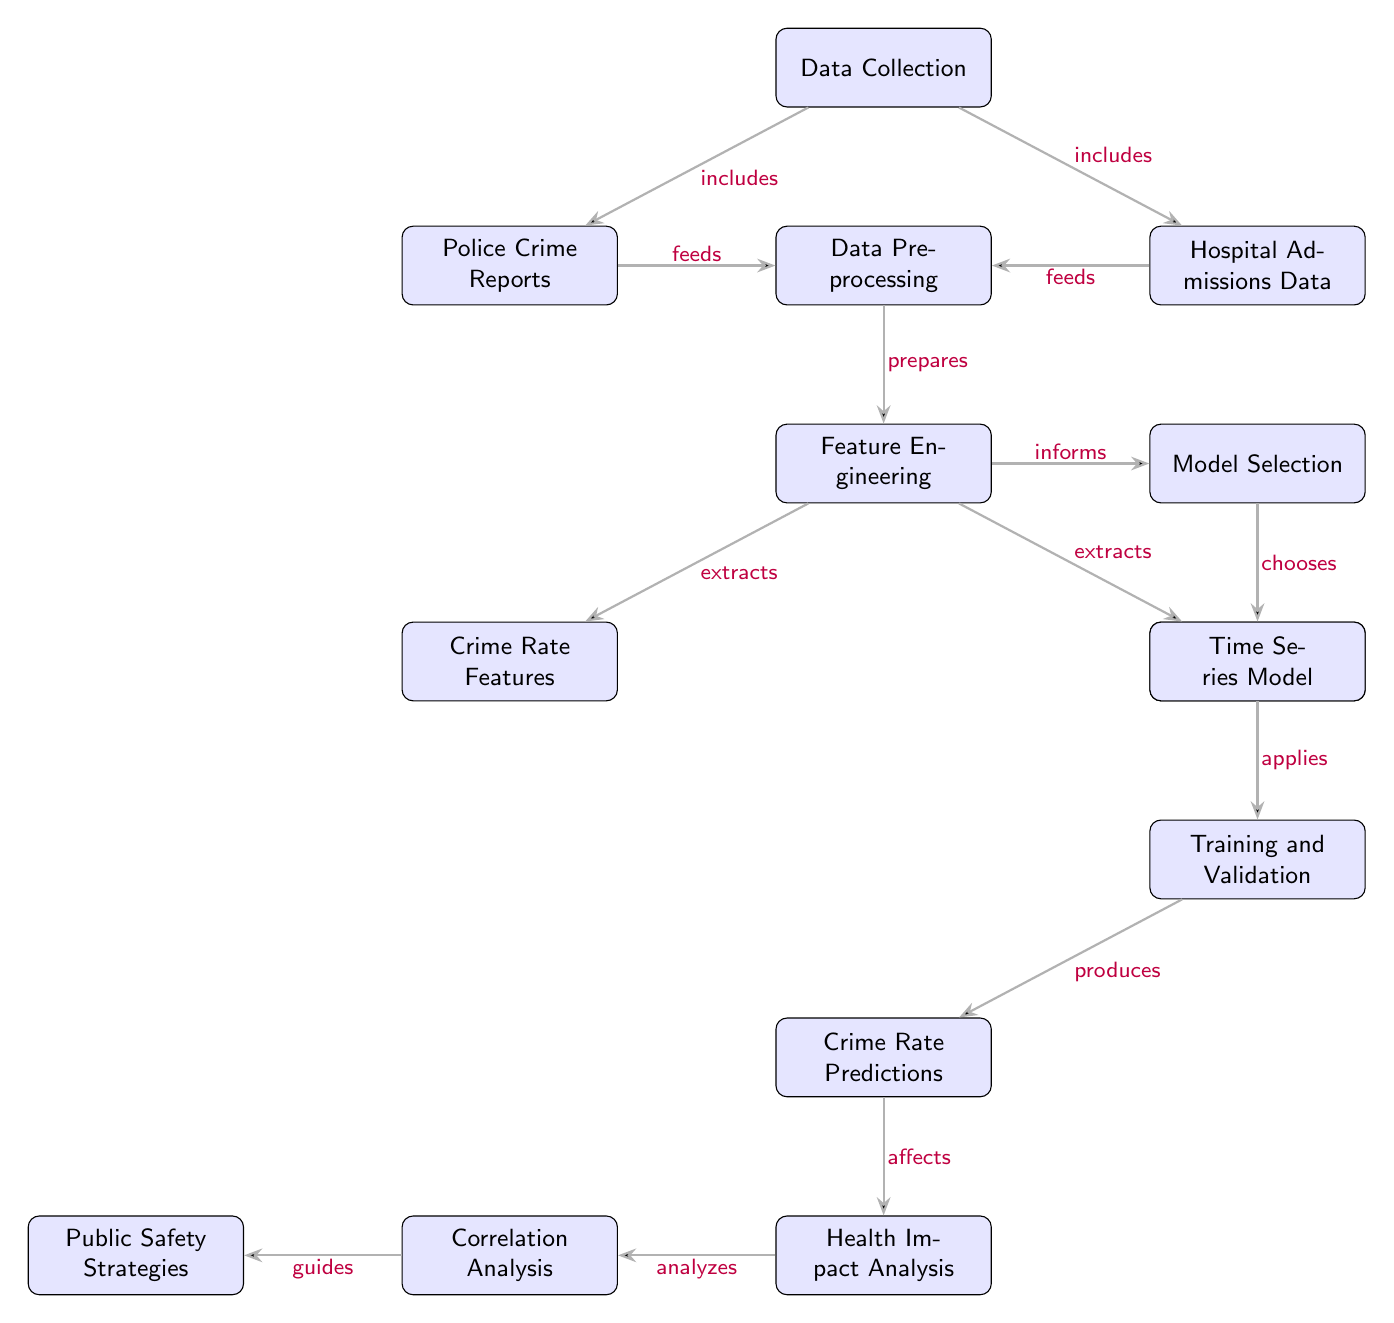What are the two main sources of data collection? The diagram clearly indicates that the two main sources of data collection are "Police Crime Reports" and "Hospital Admissions Data," which are both represented as nodes under "Data Collection."
Answer: Police Crime Reports, Hospital Admissions Data How many intermediary steps occur between data collection and model selection? By counting the nodes between "Data Collection" and "Model Selection," we see there are three intermediary steps: "Data Preprocessing," "Feature Engineering," and "Model Selection" itself.
Answer: Three Which feature types are extracted in the feature engineering stage? The diagram specifies that feature engineering extracts "Crime Rate Features" and "Health Admission Features," showing two distinct feature types in this step.
Answer: Crime Rate Features, Health Admission Features What does the node "Training and Validation" produce? According to the flow of the diagram, "Training and Validation" produces "Crime Rate Predictions," illustrating the output directly linked to this stage.
Answer: Crime Rate Predictions How are public safety strategies influenced according to the diagram? The diagram indicates that "Public Safety Strategies" are guided by "Correlation Analysis," meaning that the results of the analysis directly inform strategic decisions related to public safety.
Answer: Correlation Analysis guides public safety strategies What stage comes after model selection? In the flow of the diagram, "Time Series Model" comes immediately after "Model Selection," indicating the next step in the process following the selection phase.
Answer: Time Series Model What kind of analysis is performed after health impact analysis? The diagram specifies that "Correlation Analysis" is the next step after "Health Impact Analysis," showcasing the sequence of analyses following health-related impacts.
Answer: Correlation Analysis 